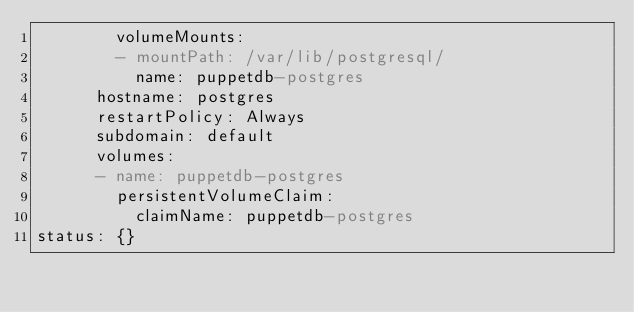Convert code to text. <code><loc_0><loc_0><loc_500><loc_500><_YAML_>        volumeMounts:
        - mountPath: /var/lib/postgresql/
          name: puppetdb-postgres
      hostname: postgres
      restartPolicy: Always
      subdomain: default
      volumes:
      - name: puppetdb-postgres
        persistentVolumeClaim:
          claimName: puppetdb-postgres
status: {}
</code> 